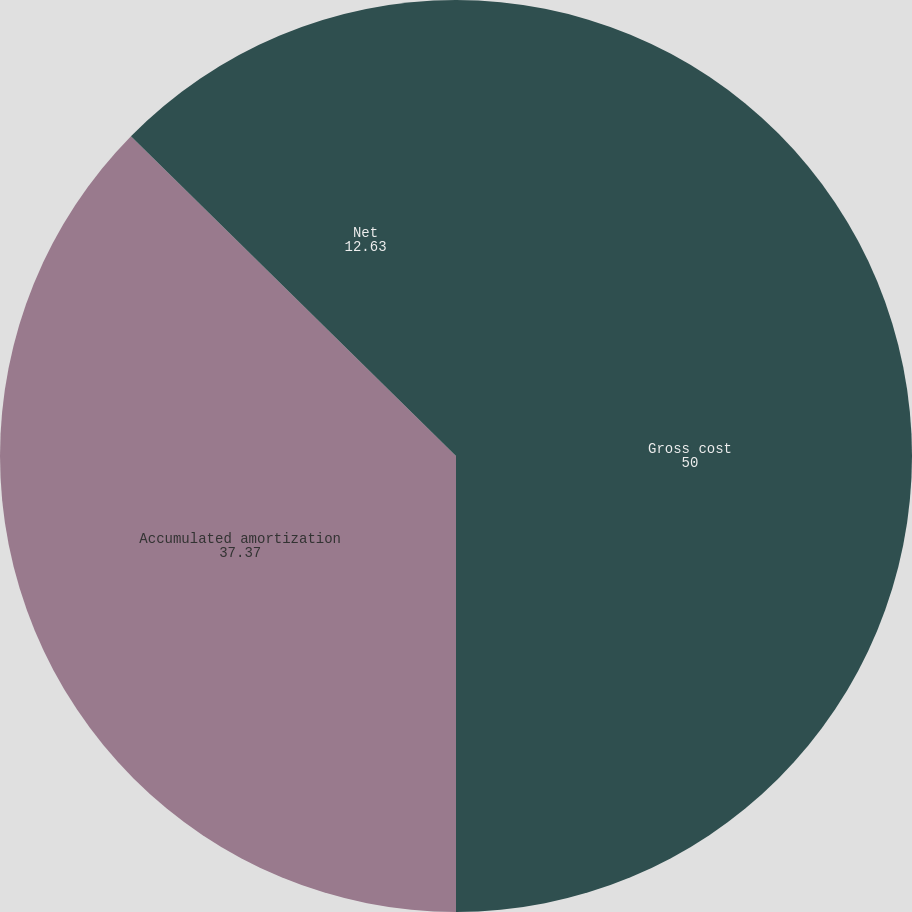Convert chart. <chart><loc_0><loc_0><loc_500><loc_500><pie_chart><fcel>Gross cost<fcel>Accumulated amortization<fcel>Net<nl><fcel>50.0%<fcel>37.37%<fcel>12.63%<nl></chart> 